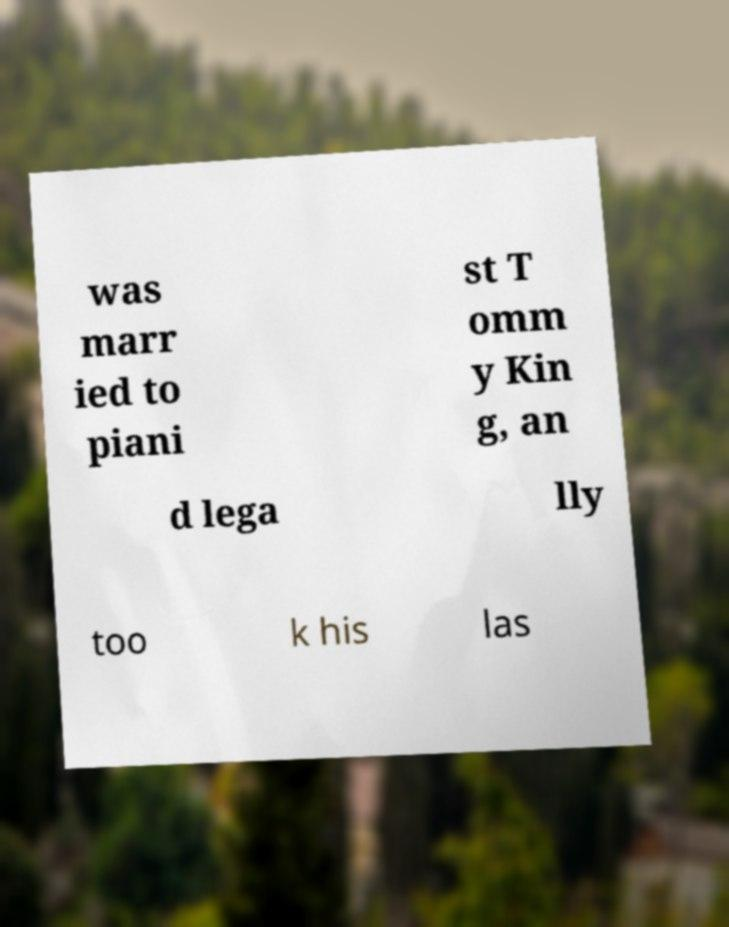I need the written content from this picture converted into text. Can you do that? was marr ied to piani st T omm y Kin g, an d lega lly too k his las 